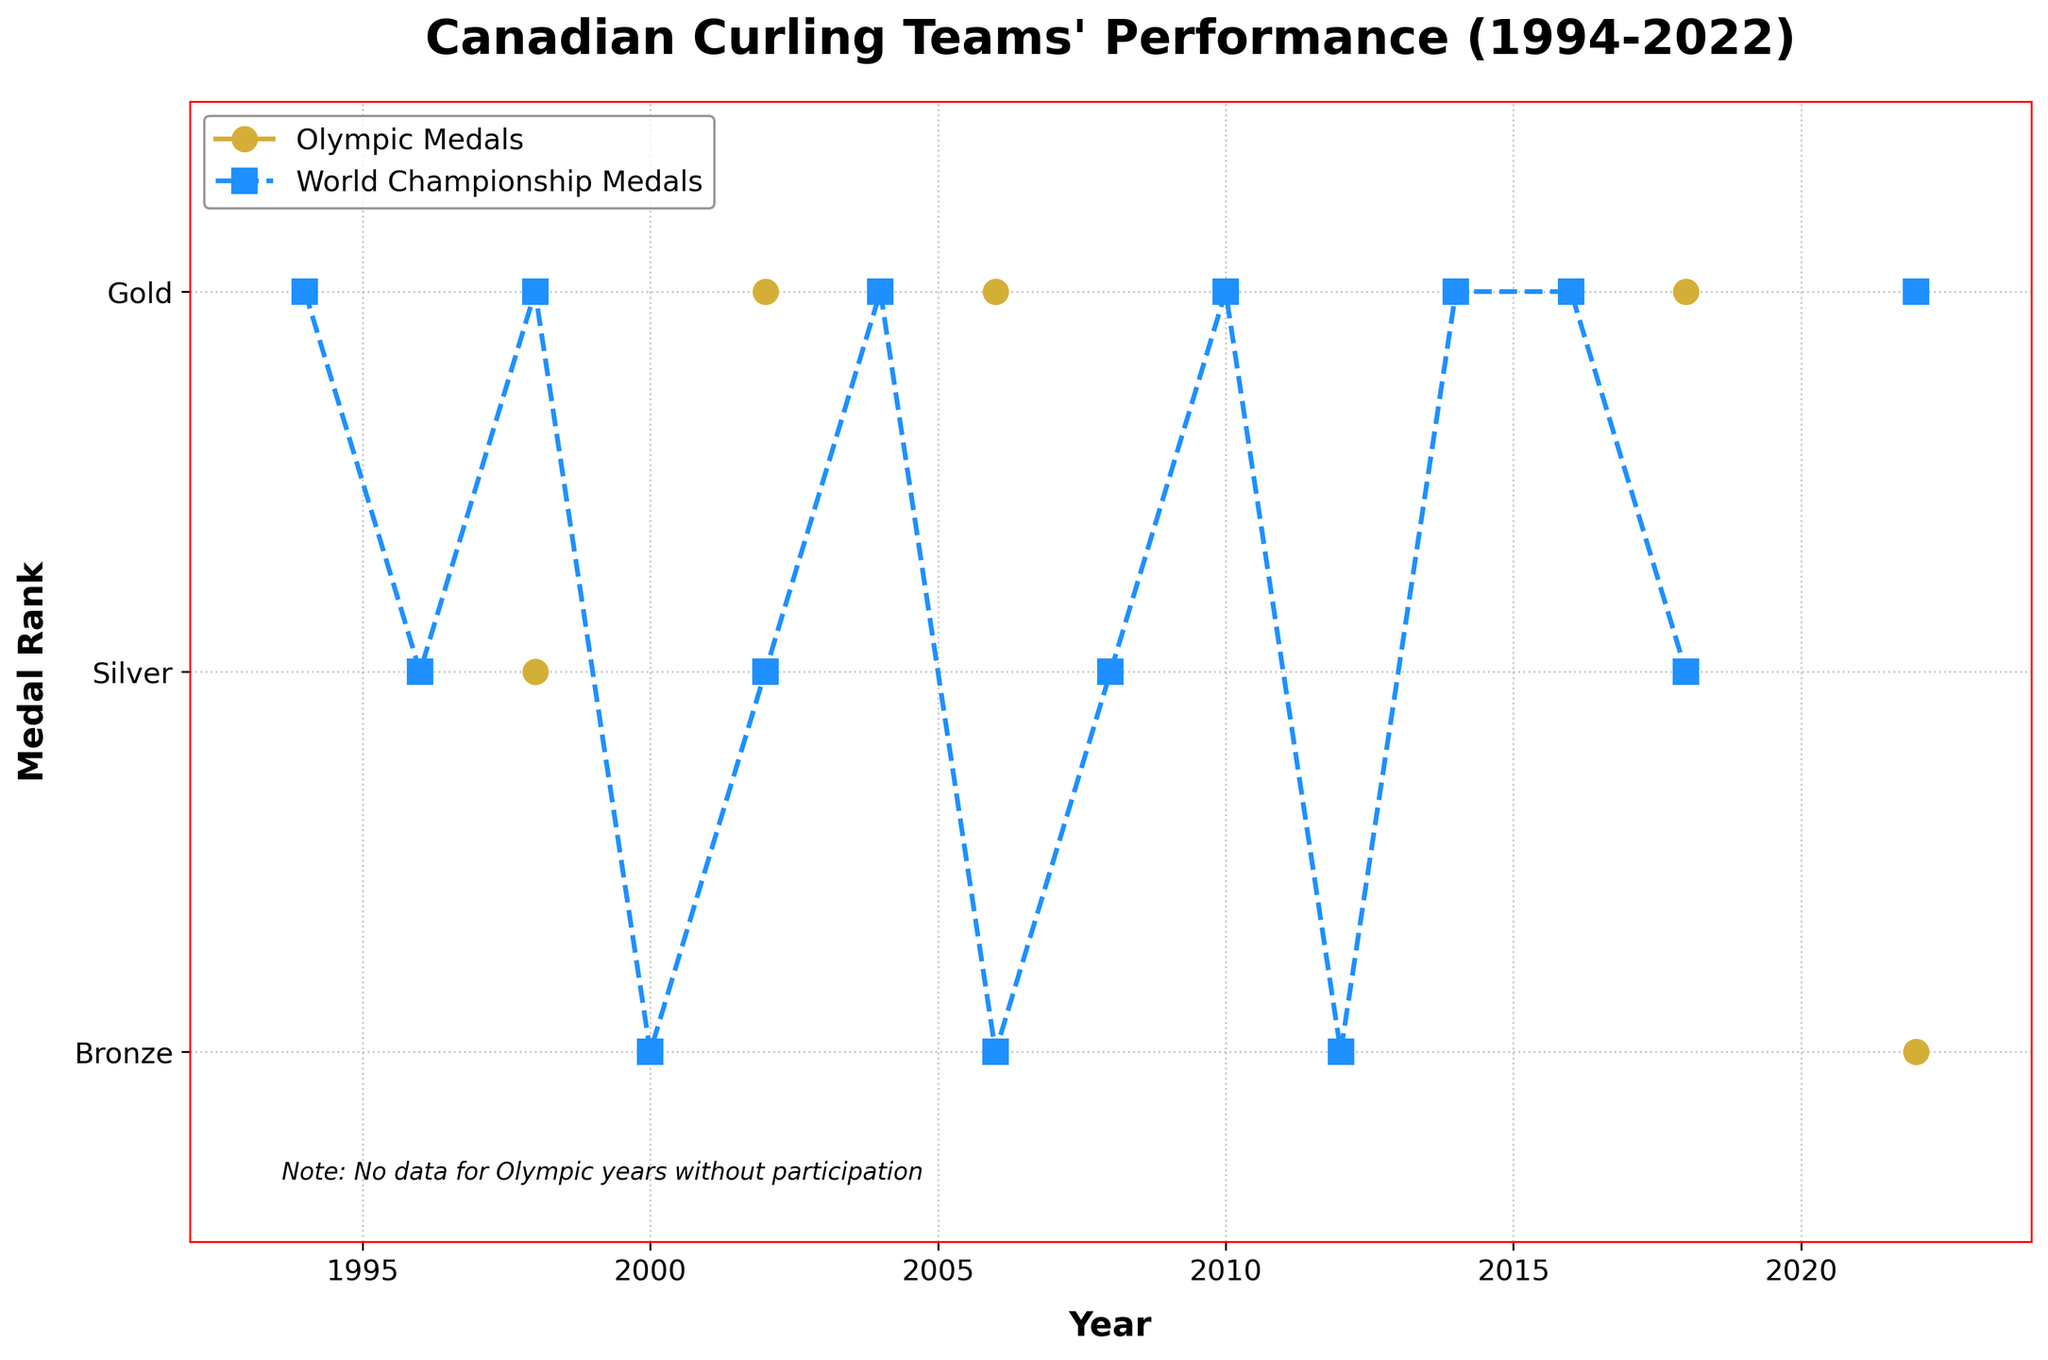What is the highest medal rank that Canadian curling teams achieved in the World Championships over the past 30 years? The highest medal rank in the World Championships is represented by the value 3, which corresponds to a Gold medal. Checking the plot, we see that Gold medals were achieved multiple times between 1994 and 2022.
Answer: Gold How many times did Canadian curling teams win Gold medals in the Olympics from 1994 to 2022? Looking at the Olympic Medals line in the plot, we identify the years with a marker at the highest position (value 3). These years are 2002, 2006, 2010, 2014, and 2018, summing up to 5 times.
Answer: 5 Compare the number of Gold medals Canada won in both the Olympics and the World Championships between 1994 and 2022. Which event did they win more frequently? Counting the Gold medals (value 3 on the y-axis) from the plot, for the Olympics: 5 (2002, 2006, 2010, 2014, 2018). For the World Championships: 6 (1994, 1998, 2004, 2010, 2014, 2016, 2022). Thus, Canada won more Golds in the World Championships.
Answer: World Championships What is the overall trend for Canadian curling teams' performance in the World Championships over the 30 years period? Observing the World Championship Medals line (blue squares), the teams mostly keep a high medal rank (Gold, Silver, Bronze) and the trend appears consistent without large gaps in medal wins, indicating strong and consistent performance.
Answer: Consistent high performance During which years did Canadian curling teams win both Olympic and World Championship Gold medals in the same year? By matching both lines at the highest level (value 3), we see overlapping Gold medals in both events during 2010 and 2014.
Answer: 2010, 2014 In which year did Canadian curling teams win their first Olympic medal and what was it? Checking the plot for the earliest Olympic medal, a Silver (value 2) was won in 1998.
Answer: 1998, Silver How often did Canadian curling teams win a medal in either the Olympics or World Championships from 1994 to 2022 where a 'None' result is shown on the plot? To find out, count the years with no markers at Olympic events (None) and any medals in World Championships: 1994 (Gold), 2000 (Bronze), 2004 (Gold), 2008 (Silver), 2012 (Bronze), 2016 (Gold). This happened 6 times.
Answer: 6 What is the difference in the number of total medals won between Olympic events and World Championships over the 30 years? Counting medals in the plot for the Olympics: 7 times (1998, 2002, 2006, 2010, 2014, 2018, 2022). For the World Championships: 13 times. The difference is 13 - 7 = 6 more medals in the World Championships.
Answer: 6 Which medal rank was less frequently won by Canada in the World Championships and by how many? Counting in the plot for World Championship: Gold (6), Silver (4), Bronze (3). Bronze was less frequently won and the difference with Gold is 6 - 3 = 3.
Answer: Bronze by 3 